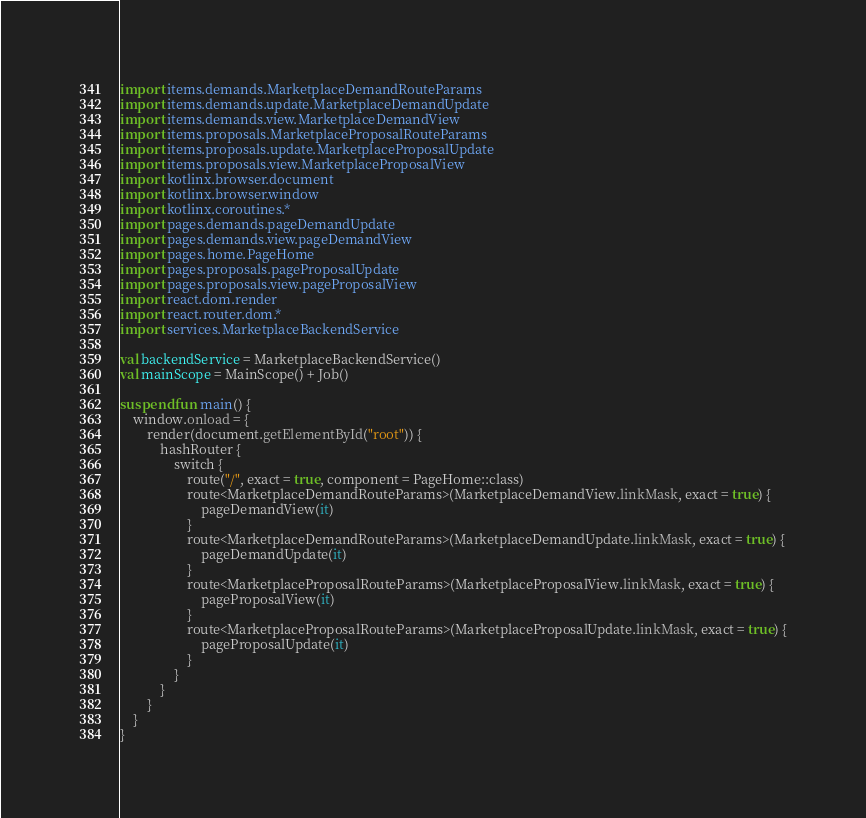<code> <loc_0><loc_0><loc_500><loc_500><_Kotlin_>import items.demands.MarketplaceDemandRouteParams
import items.demands.update.MarketplaceDemandUpdate
import items.demands.view.MarketplaceDemandView
import items.proposals.MarketplaceProposalRouteParams
import items.proposals.update.MarketplaceProposalUpdate
import items.proposals.view.MarketplaceProposalView
import kotlinx.browser.document
import kotlinx.browser.window
import kotlinx.coroutines.*
import pages.demands.pageDemandUpdate
import pages.demands.view.pageDemandView
import pages.home.PageHome
import pages.proposals.pageProposalUpdate
import pages.proposals.view.pageProposalView
import react.dom.render
import react.router.dom.*
import services.MarketplaceBackendService

val backendService = MarketplaceBackendService()
val mainScope = MainScope() + Job()

suspend fun main() {
    window.onload = {
        render(document.getElementById("root")) {
            hashRouter {
                switch {
                    route("/", exact = true, component = PageHome::class)
                    route<MarketplaceDemandRouteParams>(MarketplaceDemandView.linkMask, exact = true) {
                        pageDemandView(it)
                    }
                    route<MarketplaceDemandRouteParams>(MarketplaceDemandUpdate.linkMask, exact = true) {
                        pageDemandUpdate(it)
                    }
                    route<MarketplaceProposalRouteParams>(MarketplaceProposalView.linkMask, exact = true) {
                        pageProposalView(it)
                    }
                    route<MarketplaceProposalRouteParams>(MarketplaceProposalUpdate.linkMask, exact = true) {
                        pageProposalUpdate(it)
                    }
                }
            }
        }
    }
}

</code> 